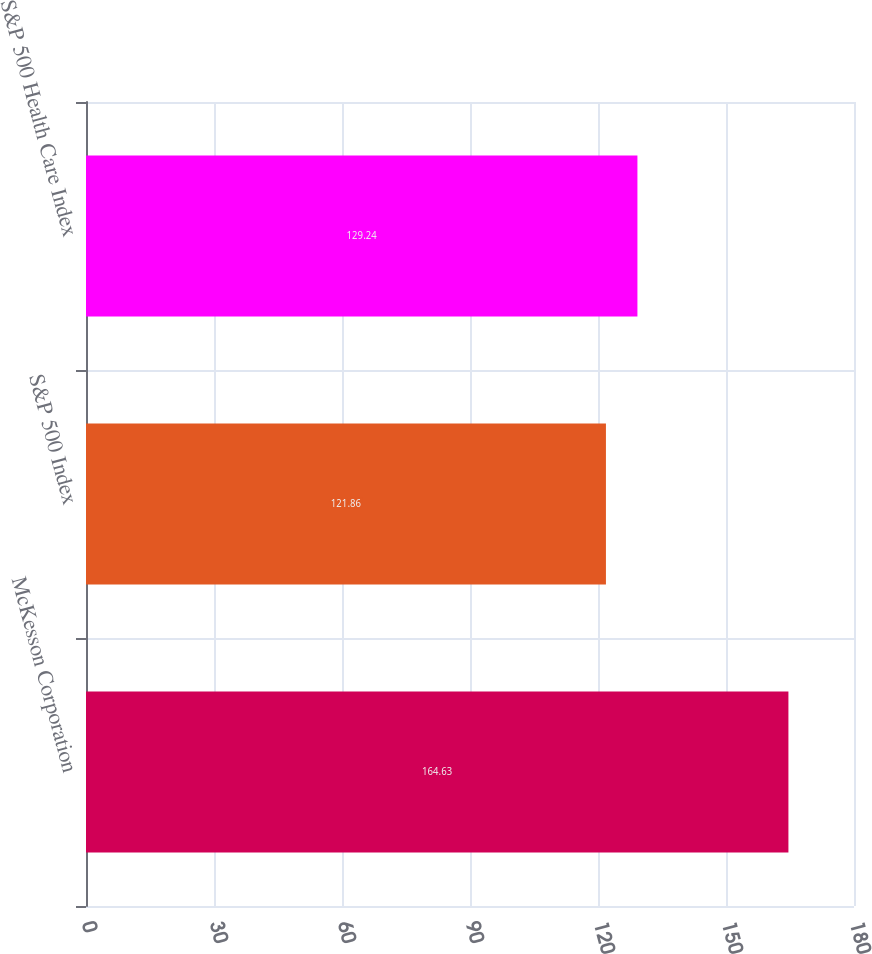<chart> <loc_0><loc_0><loc_500><loc_500><bar_chart><fcel>McKesson Corporation<fcel>S&P 500 Index<fcel>S&P 500 Health Care Index<nl><fcel>164.63<fcel>121.86<fcel>129.24<nl></chart> 